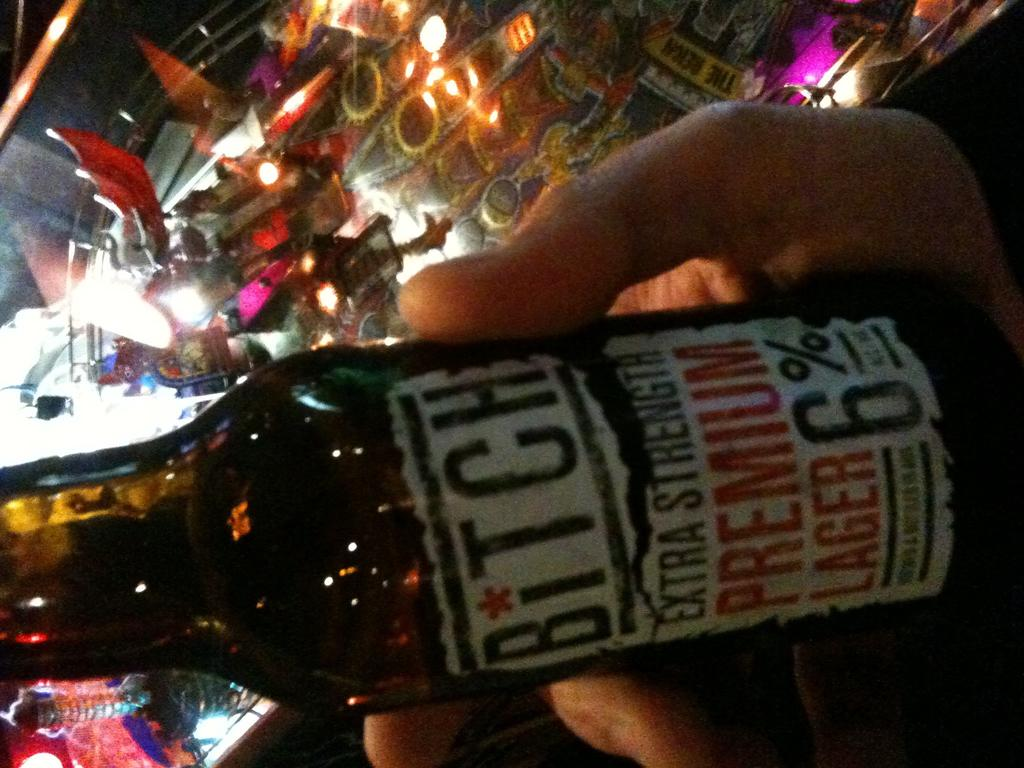Provide a one-sentence caption for the provided image. Someone holding a bottle of bitch in a bar. 